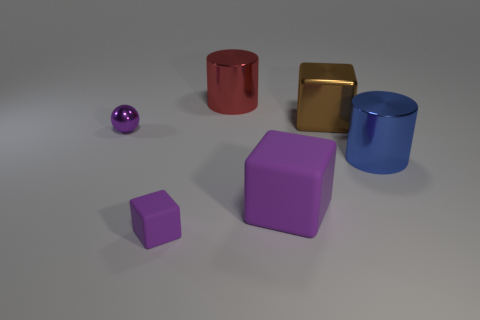Add 3 small things. How many objects exist? 9 Subtract all spheres. How many objects are left? 5 Add 4 large shiny cubes. How many large shiny cubes are left? 5 Add 1 small purple blocks. How many small purple blocks exist? 2 Subtract 0 gray cylinders. How many objects are left? 6 Subtract all metallic blocks. Subtract all purple matte objects. How many objects are left? 3 